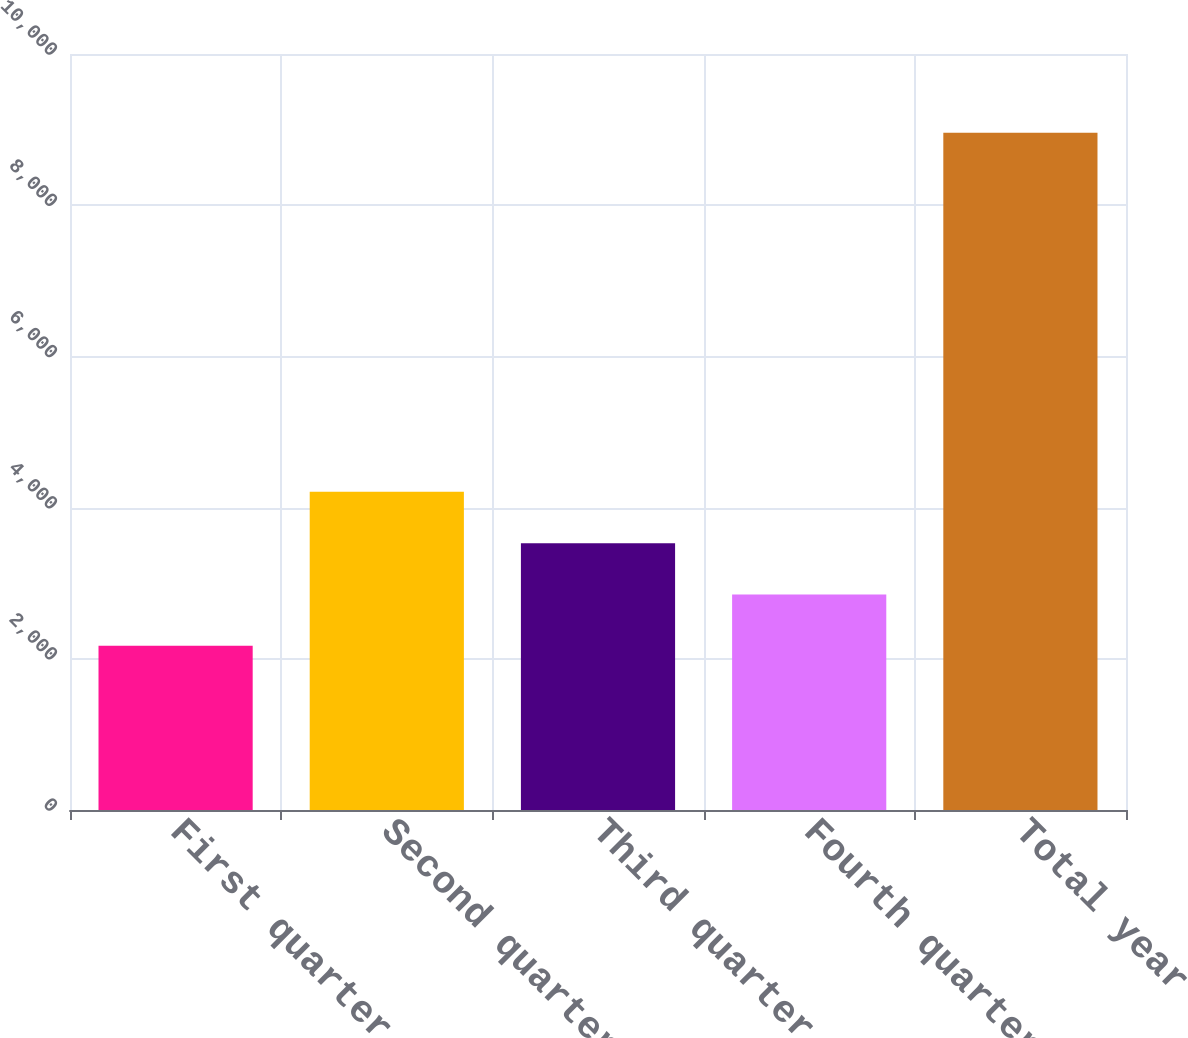<chart> <loc_0><loc_0><loc_500><loc_500><bar_chart><fcel>First quarter<fcel>Second quarter<fcel>Third quarter<fcel>Fourth quarter<fcel>Total year<nl><fcel>2172<fcel>4208.13<fcel>3529.42<fcel>2850.71<fcel>8959.1<nl></chart> 